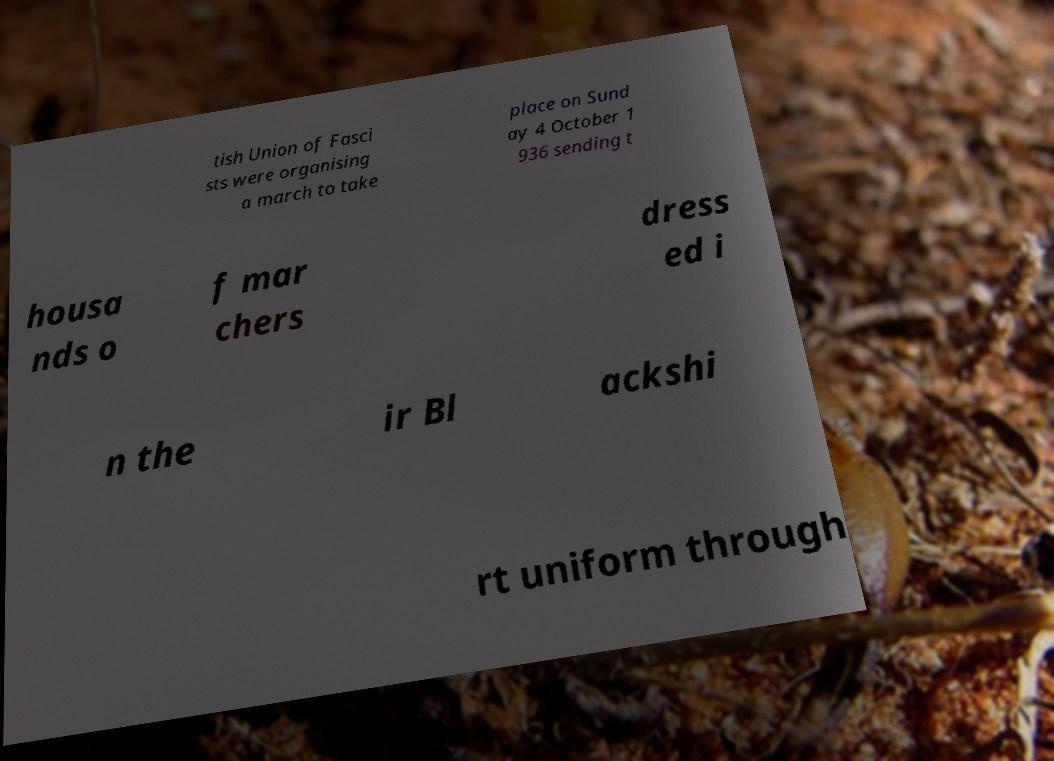Could you assist in decoding the text presented in this image and type it out clearly? tish Union of Fasci sts were organising a march to take place on Sund ay 4 October 1 936 sending t housa nds o f mar chers dress ed i n the ir Bl ackshi rt uniform through 